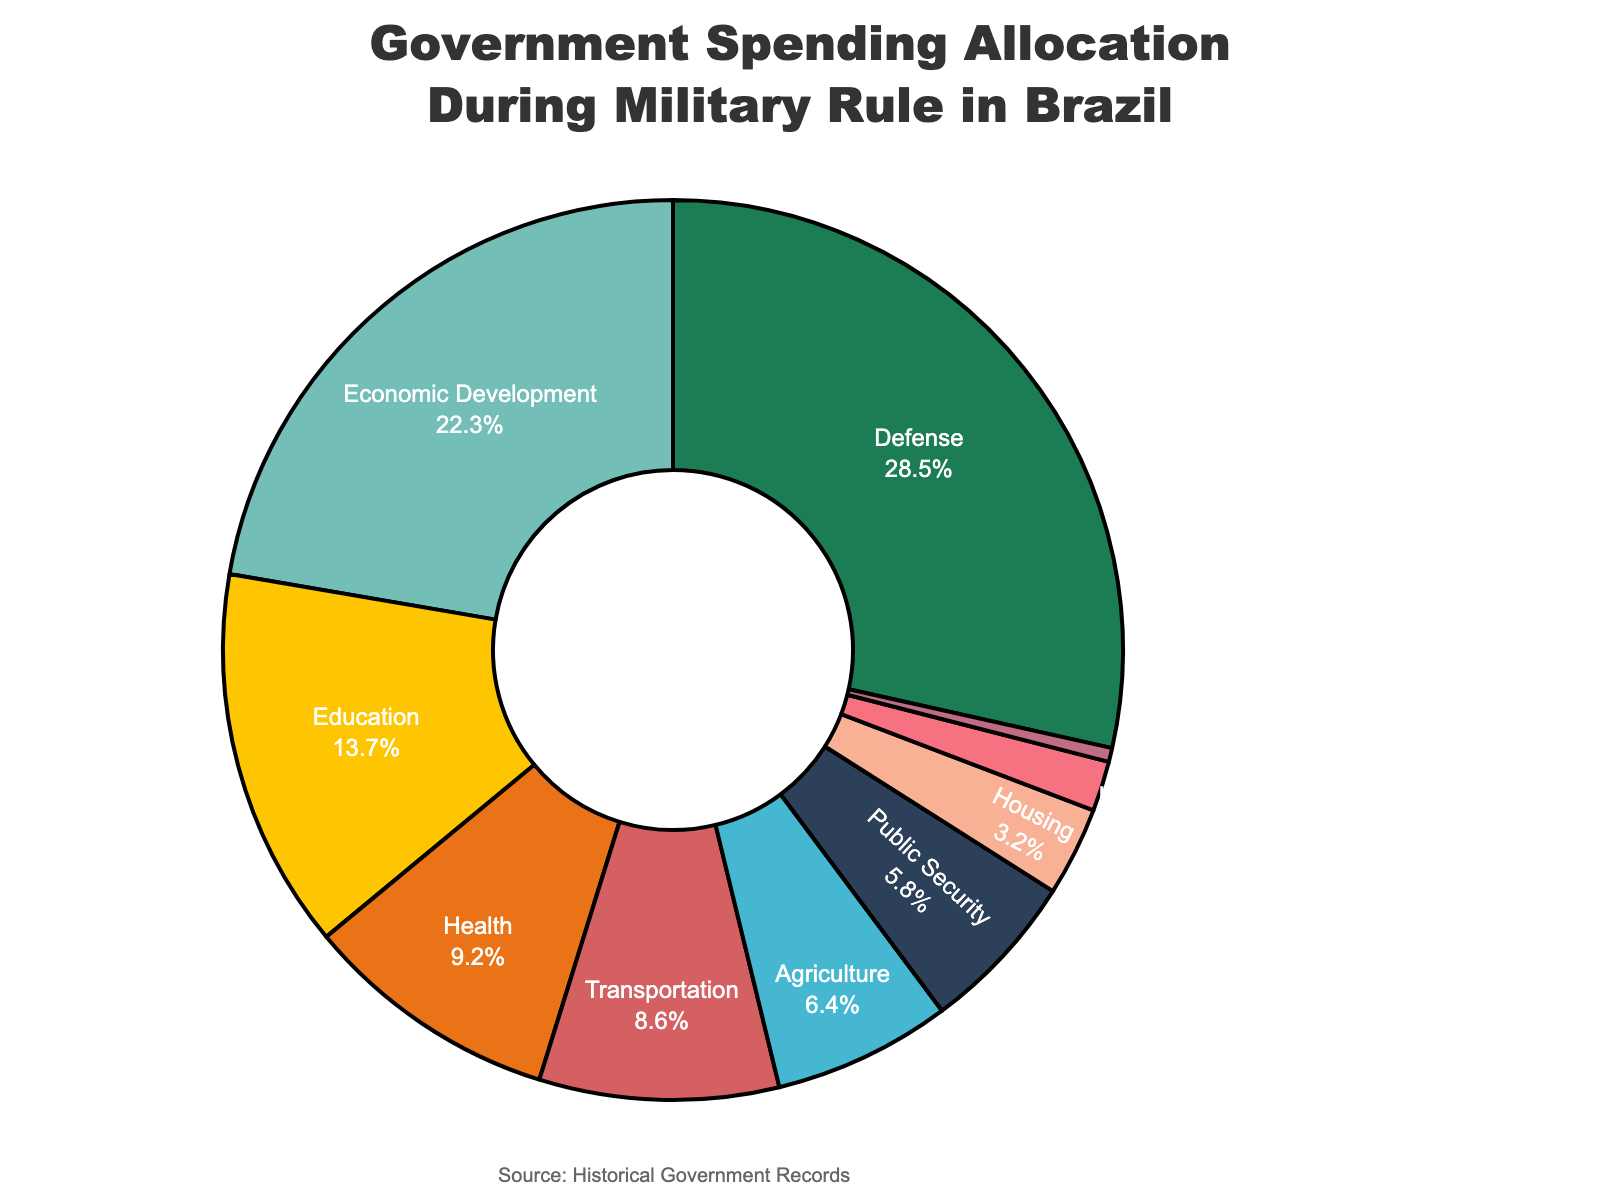What is the largest sector in terms of government spending? The largest sector is the one with the highest percentage in the pie chart. Here, Defense occupies the largest portion.
Answer: Defense How much more spending does the Defense sector receive compared to Education? To find the difference in spending, subtract the percentage allocated to Education from that allocated to Defense (28.5 - 13.7).
Answer: 14.8 If we combine the spending on Agriculture and Housing, how much is that as a percentage? Add the percentages for Agriculture and Housing (6.4 + 3.2).
Answer: 9.6% Which sectors receive less than 10% of the total government spending? The sectors with percentages less than 10% are identified by checking each sector. These are Health, Transportation, Agriculture, Public Security, Housing, Science and Technology, and Culture.
Answer: Health, Transportation, Agriculture, Public Security, Housing, Science and Technology, Culture What is the percentage difference between the spending on Economic Development and Public Security? Subtract the percentage allocated to Public Security from that allocated to Economic Development (22.3 - 5.8).
Answer: 16.5 Which sector is represented by the color green in the pie chart? The description specifies a color for each slice. Defense is represented by green (#1C7C54).
Answer: Defense Are there any sectors that receive an equal amount of government spending? By examining the percentages, no two sectors have exactly the same percentage.
Answer: No Which sector receives the second-lowest amount of government spending? The sector with the second-lowest percentage after Culture (0.5%) is Science and Technology (1.8%).
Answer: Science and Technology How much more is spent on Transportation compared to Agriculture? Subtract Agriculture's percentage from Transportation's percentage (8.6 - 6.4).
Answer: 2.2 What percentage of the total government spending is allocated to Education and Health combined? Add the percentages for Education and Health (13.7 + 9.2).
Answer: 22.9% 